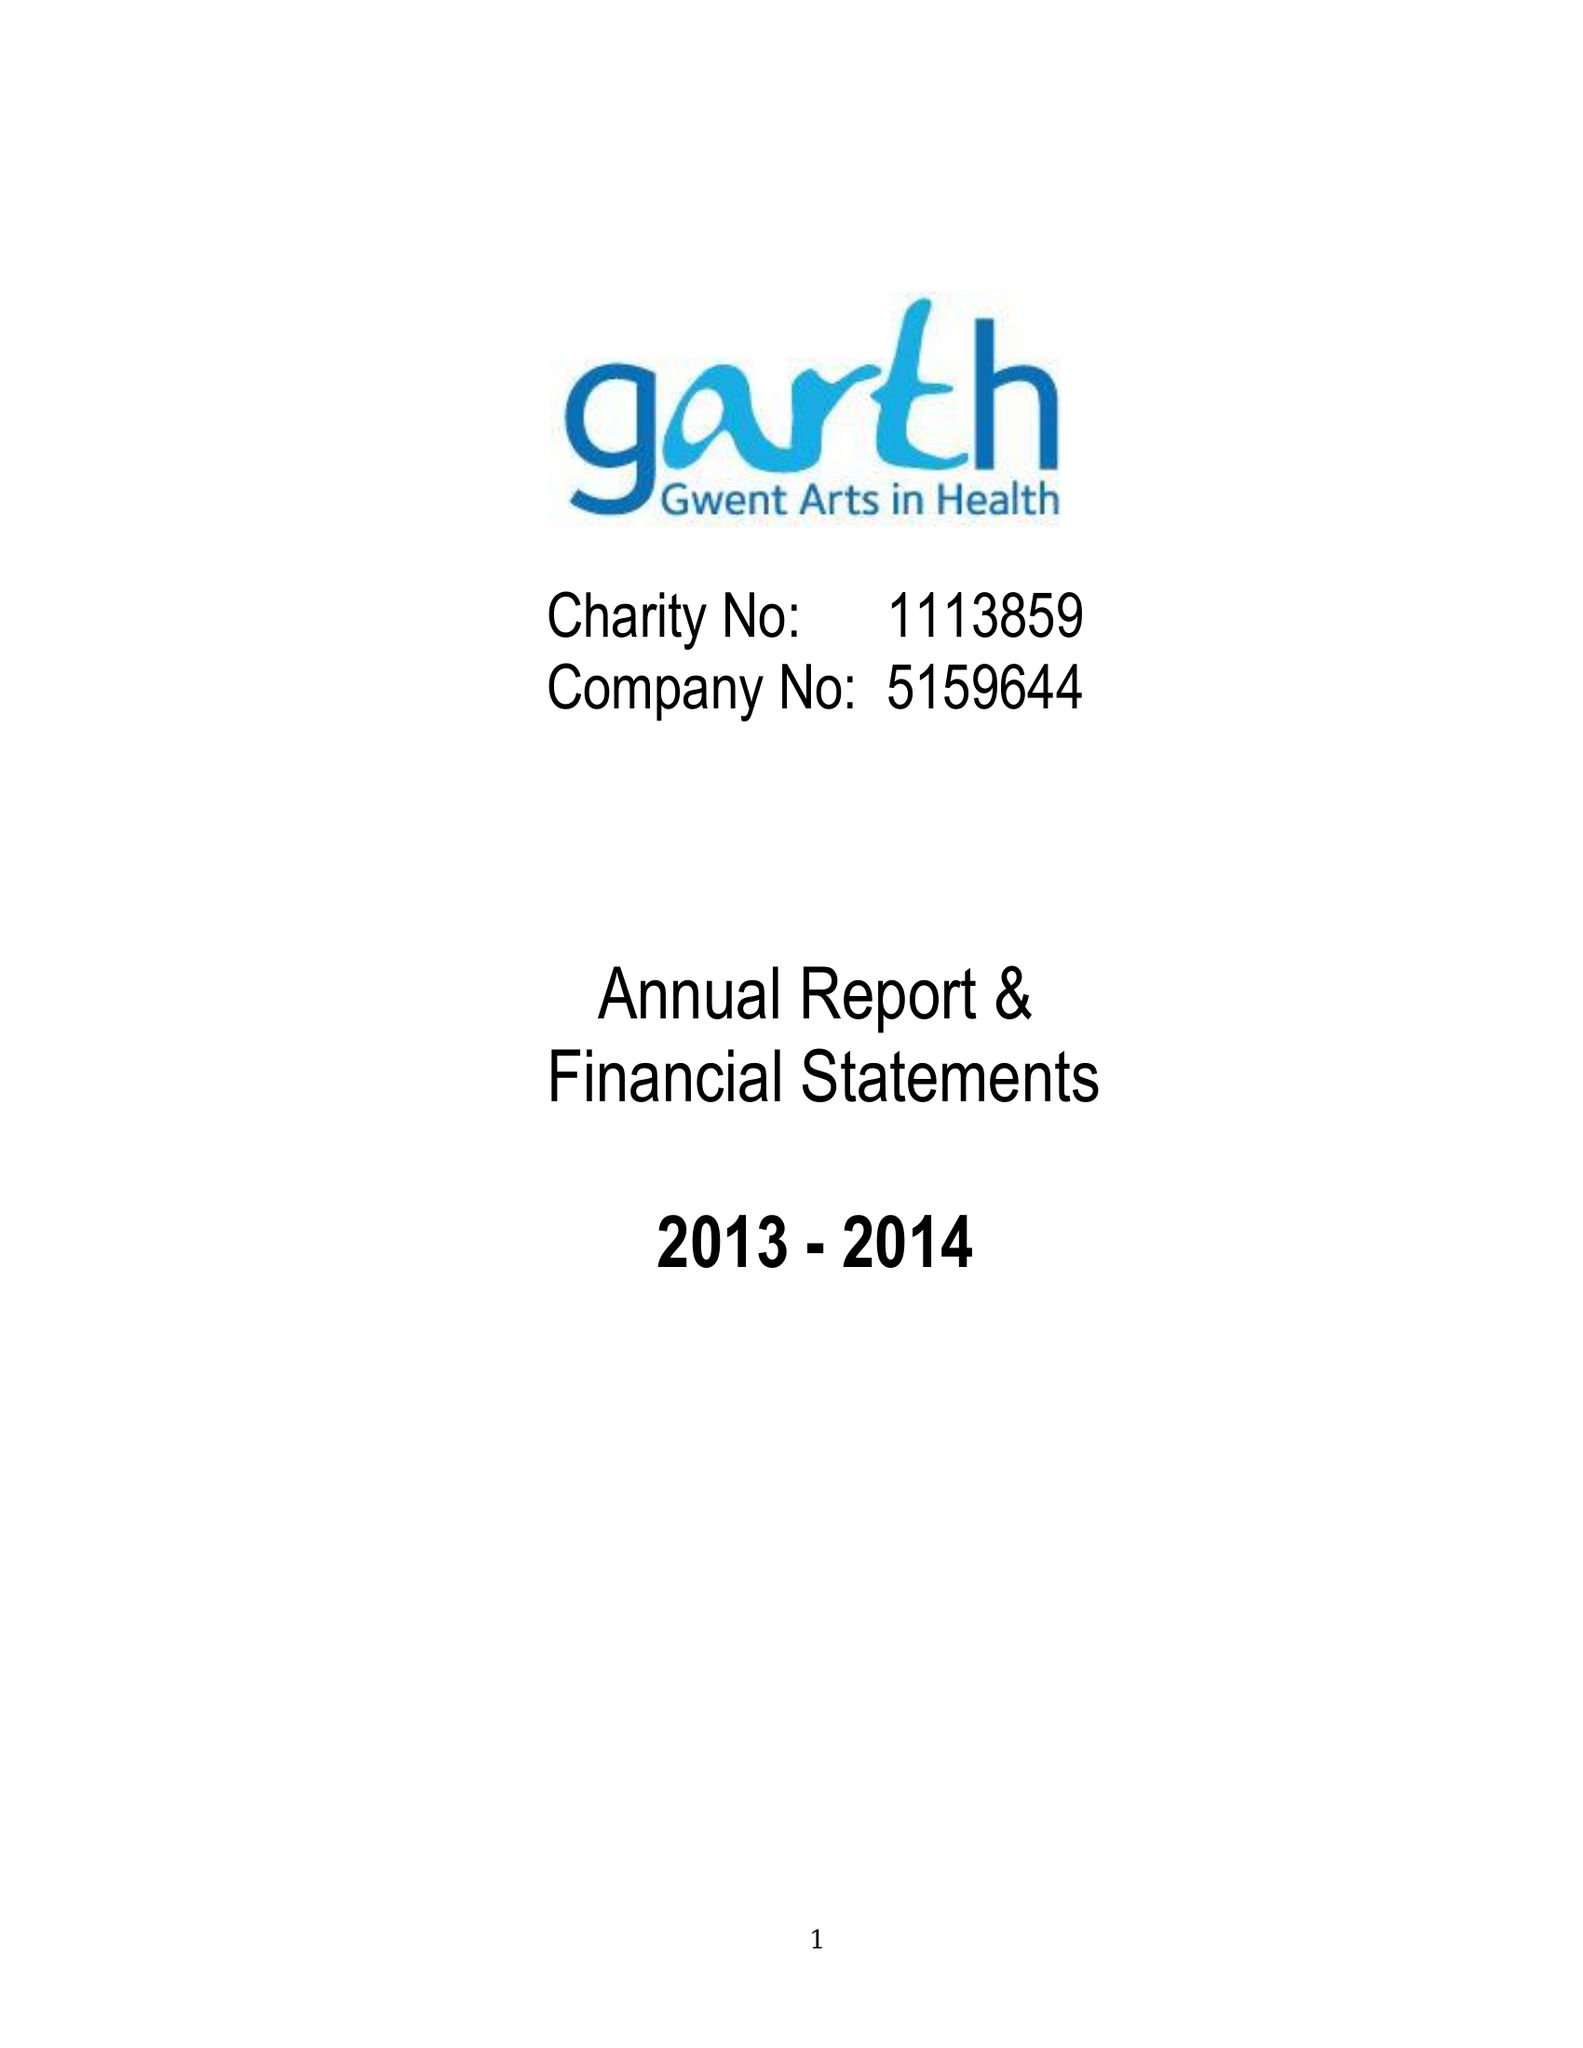What is the value for the spending_annually_in_british_pounds?
Answer the question using a single word or phrase. 45598.00 